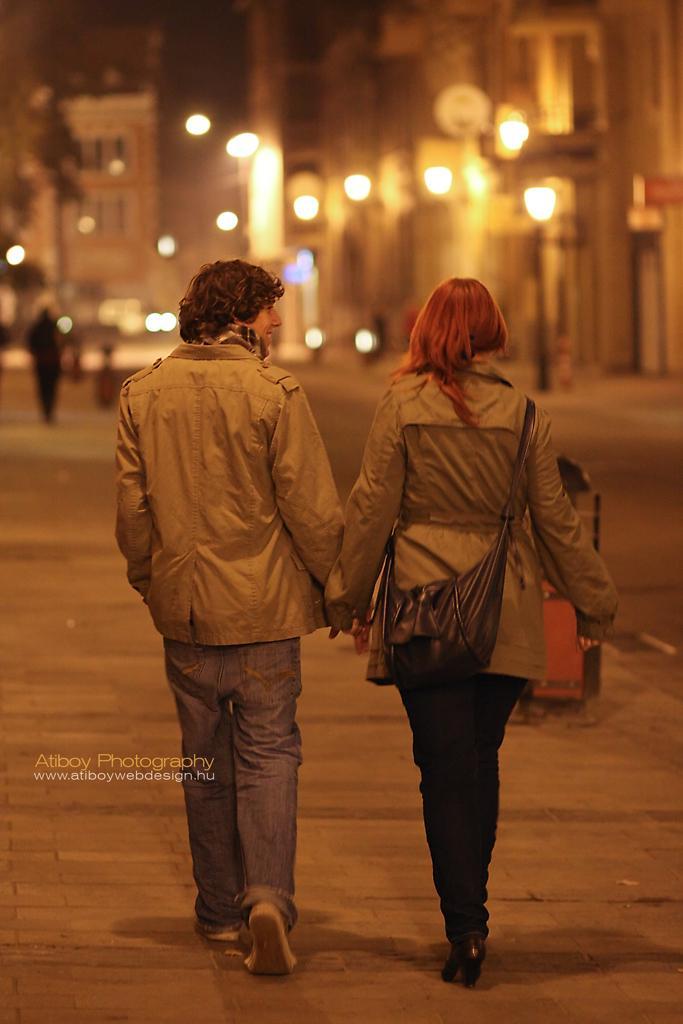Could you give a brief overview of what you see in this image? This is the picture of a guy and a lady who are wearing jackets and behind there are some buildings, lights. 